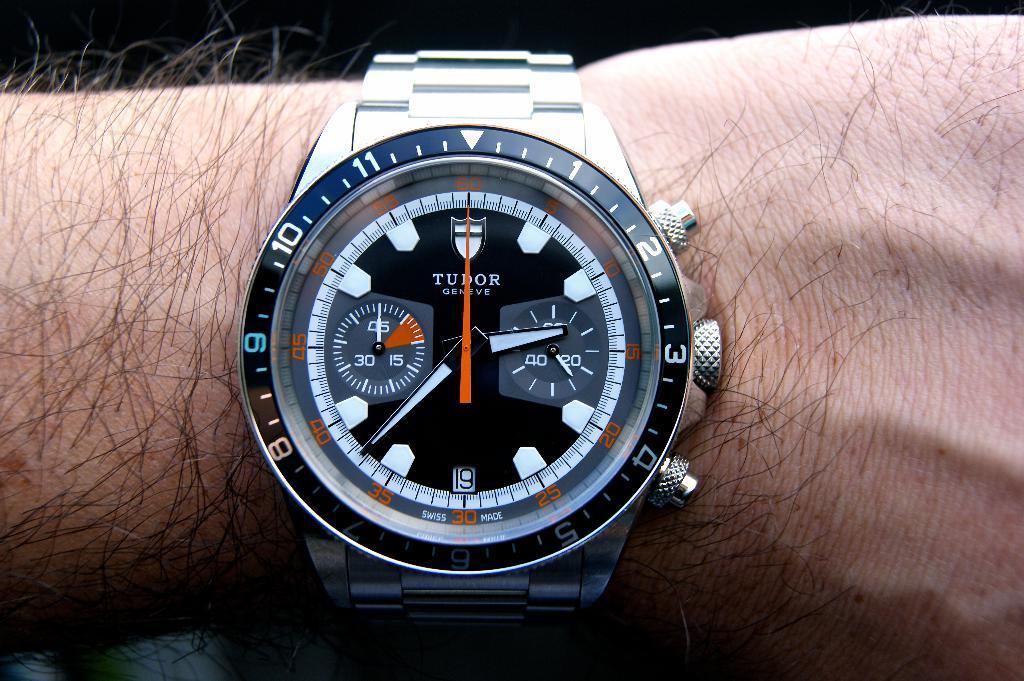Please provide a concise description of this image. In this image we can see the hand of a person wearing a watch. 